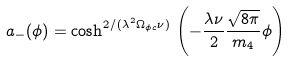Convert formula to latex. <formula><loc_0><loc_0><loc_500><loc_500>a _ { - } ( \phi ) = \cosh ^ { 2 / ( \lambda ^ { 2 } \Omega _ { \phi c } \nu ) } \, \left ( - \frac { \lambda \nu } { 2 } \frac { \sqrt { 8 \pi } } { m _ { 4 } } \phi \right )</formula> 